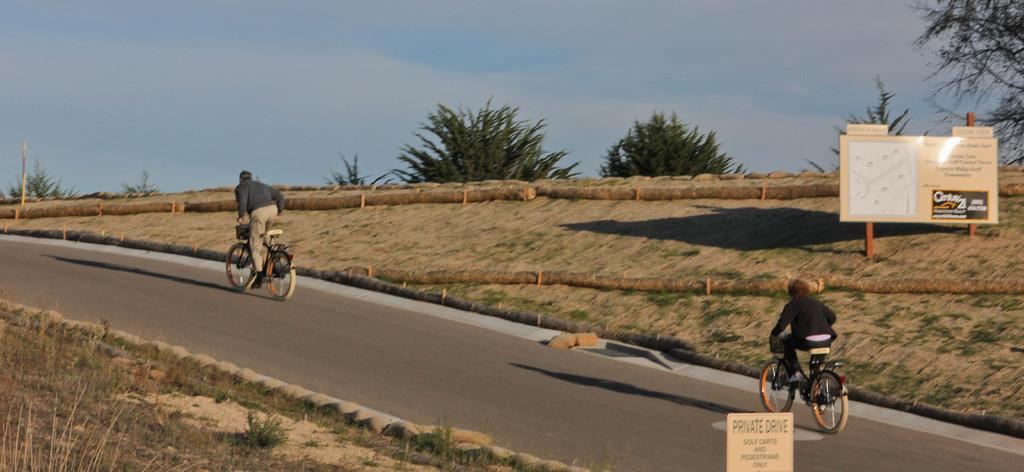Please provide a concise description of this image. In this image, there are a few people riding bicycles. We can see the ground with some objects. We can also see some grass, plants and trees. We can also see the sky and some boards with text and images. 